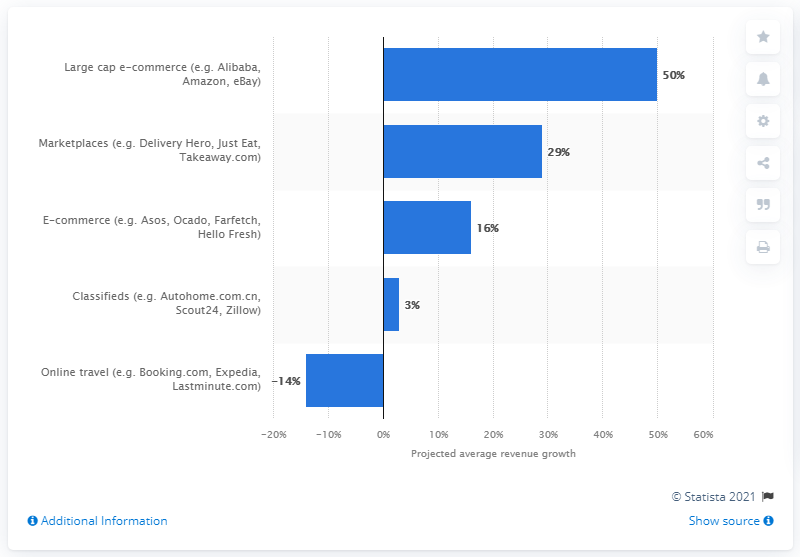Indicate a few pertinent items in this graphic. The online marketplace is projected to increase revenues by 29% in 2021. 